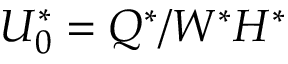Convert formula to latex. <formula><loc_0><loc_0><loc_500><loc_500>U _ { 0 } ^ { * } = Q ^ { * } / W ^ { * } H ^ { * }</formula> 